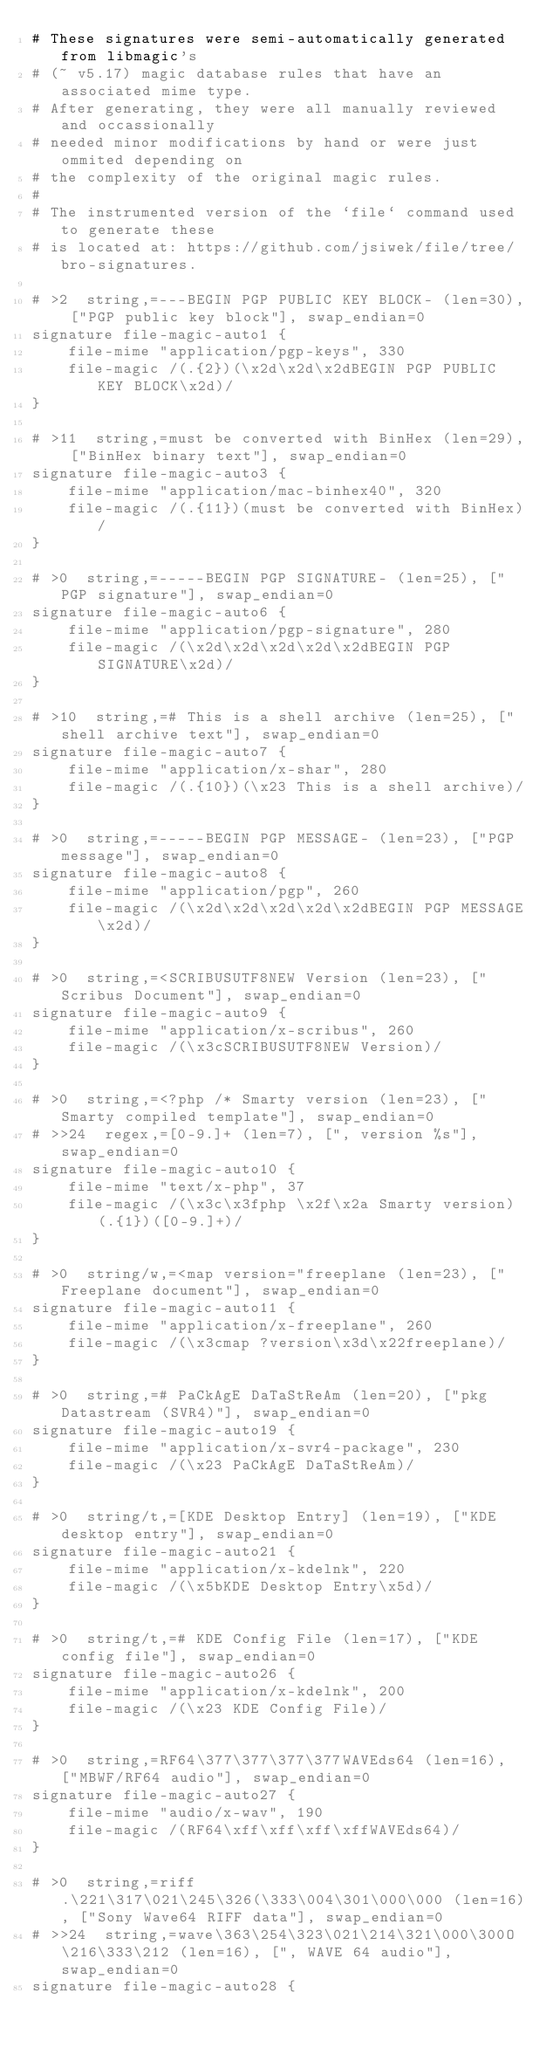<code> <loc_0><loc_0><loc_500><loc_500><_SML_># These signatures were semi-automatically generated from libmagic's
# (~ v5.17) magic database rules that have an associated mime type.
# After generating, they were all manually reviewed and occassionally
# needed minor modifications by hand or were just ommited depending on
# the complexity of the original magic rules.
#
# The instrumented version of the `file` command used to generate these
# is located at: https://github.com/jsiwek/file/tree/bro-signatures.

# >2  string,=---BEGIN PGP PUBLIC KEY BLOCK- (len=30), ["PGP public key block"], swap_endian=0
signature file-magic-auto1 {
	file-mime "application/pgp-keys", 330
	file-magic /(.{2})(\x2d\x2d\x2dBEGIN PGP PUBLIC KEY BLOCK\x2d)/
}

# >11  string,=must be converted with BinHex (len=29), ["BinHex binary text"], swap_endian=0
signature file-magic-auto3 {
	file-mime "application/mac-binhex40", 320
	file-magic /(.{11})(must be converted with BinHex)/
}

# >0  string,=-----BEGIN PGP SIGNATURE- (len=25), ["PGP signature"], swap_endian=0
signature file-magic-auto6 {
	file-mime "application/pgp-signature", 280
	file-magic /(\x2d\x2d\x2d\x2d\x2dBEGIN PGP SIGNATURE\x2d)/
}

# >10  string,=# This is a shell archive (len=25), ["shell archive text"], swap_endian=0
signature file-magic-auto7 {
	file-mime "application/x-shar", 280
	file-magic /(.{10})(\x23 This is a shell archive)/
}

# >0  string,=-----BEGIN PGP MESSAGE- (len=23), ["PGP message"], swap_endian=0
signature file-magic-auto8 {
	file-mime "application/pgp", 260
	file-magic /(\x2d\x2d\x2d\x2d\x2dBEGIN PGP MESSAGE\x2d)/
}

# >0  string,=<SCRIBUSUTF8NEW Version (len=23), ["Scribus Document"], swap_endian=0
signature file-magic-auto9 {
	file-mime "application/x-scribus", 260
	file-magic /(\x3cSCRIBUSUTF8NEW Version)/
}

# >0  string,=<?php /* Smarty version (len=23), ["Smarty compiled template"], swap_endian=0
# >>24  regex,=[0-9.]+ (len=7), [", version %s"], swap_endian=0
signature file-magic-auto10 {
	file-mime "text/x-php", 37
	file-magic /(\x3c\x3fphp \x2f\x2a Smarty version)(.{1})([0-9.]+)/
}

# >0  string/w,=<map version="freeplane (len=23), ["Freeplane document"], swap_endian=0
signature file-magic-auto11 {
	file-mime "application/x-freeplane", 260
	file-magic /(\x3cmap ?version\x3d\x22freeplane)/
}

# >0  string,=# PaCkAgE DaTaStReAm (len=20), ["pkg Datastream (SVR4)"], swap_endian=0
signature file-magic-auto19 {
	file-mime "application/x-svr4-package", 230
	file-magic /(\x23 PaCkAgE DaTaStReAm)/
}

# >0  string/t,=[KDE Desktop Entry] (len=19), ["KDE desktop entry"], swap_endian=0
signature file-magic-auto21 {
	file-mime "application/x-kdelnk", 220
	file-magic /(\x5bKDE Desktop Entry\x5d)/
}

# >0  string/t,=# KDE Config File (len=17), ["KDE config file"], swap_endian=0
signature file-magic-auto26 {
	file-mime "application/x-kdelnk", 200
	file-magic /(\x23 KDE Config File)/
}

# >0  string,=RF64\377\377\377\377WAVEds64 (len=16), ["MBWF/RF64 audio"], swap_endian=0
signature file-magic-auto27 {
	file-mime "audio/x-wav", 190
	file-magic /(RF64\xff\xff\xff\xffWAVEds64)/
}

# >0  string,=riff.\221\317\021\245\326(\333\004\301\000\000 (len=16), ["Sony Wave64 RIFF data"], swap_endian=0
# >>24  string,=wave\363\254\323\021\214\321\000\300O\216\333\212 (len=16), [", WAVE 64 audio"], swap_endian=0
signature file-magic-auto28 {</code> 